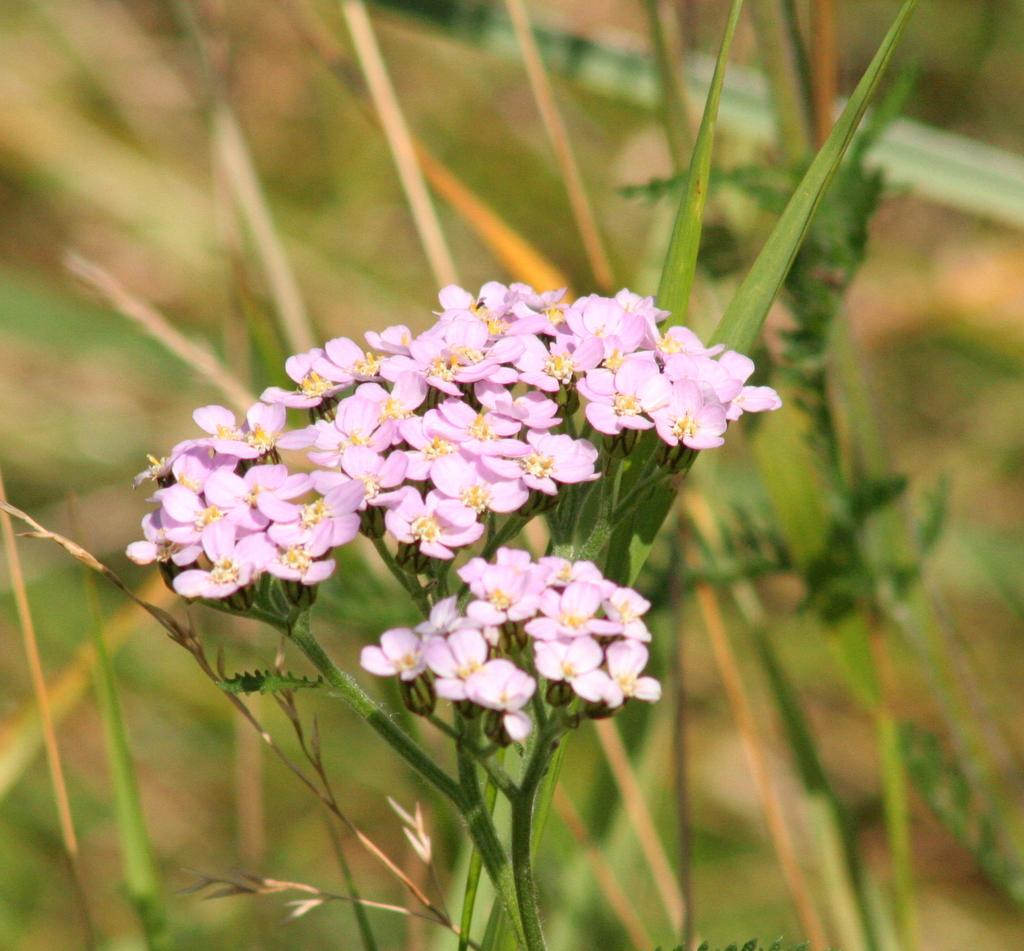What type of living organisms can be seen in the image? There are flowers and plants in the image. Can you describe the background of the image? The background of the image is blurred. What shape is the team taking in the image? There is no team present in the image, so it is not possible to determine the shape they might be taking. What type of art can be seen in the image? There is no art present in the image; it features flowers and plants. 